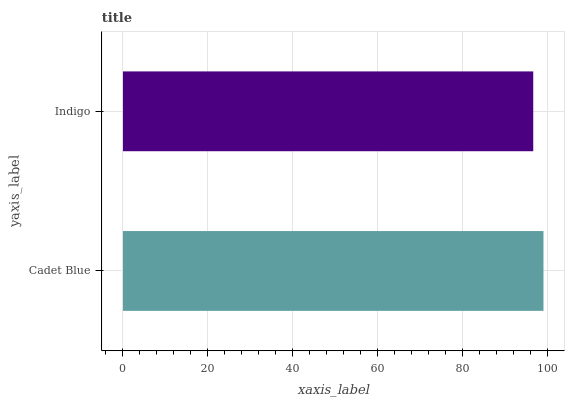Is Indigo the minimum?
Answer yes or no. Yes. Is Cadet Blue the maximum?
Answer yes or no. Yes. Is Indigo the maximum?
Answer yes or no. No. Is Cadet Blue greater than Indigo?
Answer yes or no. Yes. Is Indigo less than Cadet Blue?
Answer yes or no. Yes. Is Indigo greater than Cadet Blue?
Answer yes or no. No. Is Cadet Blue less than Indigo?
Answer yes or no. No. Is Cadet Blue the high median?
Answer yes or no. Yes. Is Indigo the low median?
Answer yes or no. Yes. Is Indigo the high median?
Answer yes or no. No. Is Cadet Blue the low median?
Answer yes or no. No. 